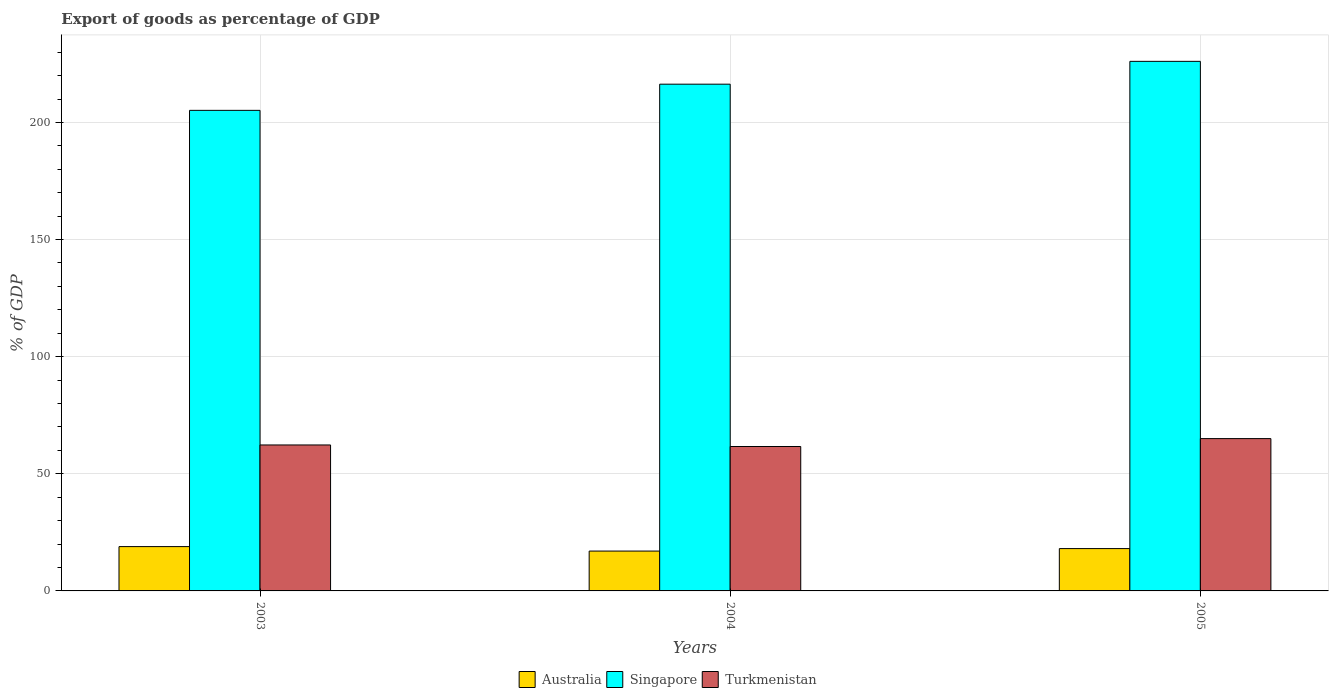Are the number of bars per tick equal to the number of legend labels?
Provide a succinct answer. Yes. How many bars are there on the 2nd tick from the right?
Your response must be concise. 3. What is the export of goods as percentage of GDP in Turkmenistan in 2005?
Provide a short and direct response. 65.03. Across all years, what is the maximum export of goods as percentage of GDP in Turkmenistan?
Offer a very short reply. 65.03. Across all years, what is the minimum export of goods as percentage of GDP in Singapore?
Give a very brief answer. 205.16. In which year was the export of goods as percentage of GDP in Australia maximum?
Provide a succinct answer. 2003. In which year was the export of goods as percentage of GDP in Turkmenistan minimum?
Keep it short and to the point. 2004. What is the total export of goods as percentage of GDP in Australia in the graph?
Your answer should be compact. 54.01. What is the difference between the export of goods as percentage of GDP in Australia in 2003 and that in 2004?
Offer a very short reply. 1.91. What is the difference between the export of goods as percentage of GDP in Turkmenistan in 2005 and the export of goods as percentage of GDP in Singapore in 2004?
Ensure brevity in your answer.  -151.31. What is the average export of goods as percentage of GDP in Singapore per year?
Provide a succinct answer. 215.86. In the year 2005, what is the difference between the export of goods as percentage of GDP in Australia and export of goods as percentage of GDP in Turkmenistan?
Provide a succinct answer. -46.95. In how many years, is the export of goods as percentage of GDP in Turkmenistan greater than 170 %?
Your answer should be compact. 0. What is the ratio of the export of goods as percentage of GDP in Turkmenistan in 2003 to that in 2005?
Keep it short and to the point. 0.96. Is the difference between the export of goods as percentage of GDP in Australia in 2003 and 2005 greater than the difference between the export of goods as percentage of GDP in Turkmenistan in 2003 and 2005?
Ensure brevity in your answer.  Yes. What is the difference between the highest and the second highest export of goods as percentage of GDP in Turkmenistan?
Ensure brevity in your answer.  2.72. What is the difference between the highest and the lowest export of goods as percentage of GDP in Singapore?
Your answer should be very brief. 20.92. In how many years, is the export of goods as percentage of GDP in Turkmenistan greater than the average export of goods as percentage of GDP in Turkmenistan taken over all years?
Provide a short and direct response. 1. Is the sum of the export of goods as percentage of GDP in Singapore in 2003 and 2005 greater than the maximum export of goods as percentage of GDP in Turkmenistan across all years?
Provide a succinct answer. Yes. What does the 2nd bar from the left in 2004 represents?
Keep it short and to the point. Singapore. Are all the bars in the graph horizontal?
Give a very brief answer. No. How many years are there in the graph?
Give a very brief answer. 3. Where does the legend appear in the graph?
Keep it short and to the point. Bottom center. How many legend labels are there?
Make the answer very short. 3. How are the legend labels stacked?
Keep it short and to the point. Horizontal. What is the title of the graph?
Provide a succinct answer. Export of goods as percentage of GDP. Does "United Kingdom" appear as one of the legend labels in the graph?
Keep it short and to the point. No. What is the label or title of the Y-axis?
Your response must be concise. % of GDP. What is the % of GDP of Australia in 2003?
Offer a very short reply. 18.92. What is the % of GDP in Singapore in 2003?
Your answer should be compact. 205.16. What is the % of GDP of Turkmenistan in 2003?
Give a very brief answer. 62.31. What is the % of GDP in Australia in 2004?
Your answer should be compact. 17.01. What is the % of GDP in Singapore in 2004?
Ensure brevity in your answer.  216.34. What is the % of GDP of Turkmenistan in 2004?
Your answer should be compact. 61.65. What is the % of GDP of Australia in 2005?
Offer a very short reply. 18.07. What is the % of GDP in Singapore in 2005?
Ensure brevity in your answer.  226.08. What is the % of GDP of Turkmenistan in 2005?
Keep it short and to the point. 65.03. Across all years, what is the maximum % of GDP of Australia?
Provide a short and direct response. 18.92. Across all years, what is the maximum % of GDP of Singapore?
Give a very brief answer. 226.08. Across all years, what is the maximum % of GDP in Turkmenistan?
Give a very brief answer. 65.03. Across all years, what is the minimum % of GDP in Australia?
Provide a succinct answer. 17.01. Across all years, what is the minimum % of GDP in Singapore?
Keep it short and to the point. 205.16. Across all years, what is the minimum % of GDP of Turkmenistan?
Your answer should be very brief. 61.65. What is the total % of GDP of Australia in the graph?
Your answer should be very brief. 54.01. What is the total % of GDP of Singapore in the graph?
Provide a short and direct response. 647.58. What is the total % of GDP in Turkmenistan in the graph?
Provide a succinct answer. 188.99. What is the difference between the % of GDP in Australia in 2003 and that in 2004?
Give a very brief answer. 1.91. What is the difference between the % of GDP in Singapore in 2003 and that in 2004?
Provide a succinct answer. -11.17. What is the difference between the % of GDP of Turkmenistan in 2003 and that in 2004?
Offer a terse response. 0.66. What is the difference between the % of GDP of Australia in 2003 and that in 2005?
Give a very brief answer. 0.85. What is the difference between the % of GDP in Singapore in 2003 and that in 2005?
Provide a succinct answer. -20.92. What is the difference between the % of GDP of Turkmenistan in 2003 and that in 2005?
Your answer should be compact. -2.72. What is the difference between the % of GDP in Australia in 2004 and that in 2005?
Keep it short and to the point. -1.06. What is the difference between the % of GDP of Singapore in 2004 and that in 2005?
Provide a succinct answer. -9.74. What is the difference between the % of GDP of Turkmenistan in 2004 and that in 2005?
Offer a terse response. -3.37. What is the difference between the % of GDP in Australia in 2003 and the % of GDP in Singapore in 2004?
Your response must be concise. -197.41. What is the difference between the % of GDP of Australia in 2003 and the % of GDP of Turkmenistan in 2004?
Give a very brief answer. -42.73. What is the difference between the % of GDP in Singapore in 2003 and the % of GDP in Turkmenistan in 2004?
Give a very brief answer. 143.51. What is the difference between the % of GDP in Australia in 2003 and the % of GDP in Singapore in 2005?
Provide a short and direct response. -207.16. What is the difference between the % of GDP in Australia in 2003 and the % of GDP in Turkmenistan in 2005?
Offer a terse response. -46.1. What is the difference between the % of GDP of Singapore in 2003 and the % of GDP of Turkmenistan in 2005?
Your response must be concise. 140.13. What is the difference between the % of GDP of Australia in 2004 and the % of GDP of Singapore in 2005?
Keep it short and to the point. -209.07. What is the difference between the % of GDP of Australia in 2004 and the % of GDP of Turkmenistan in 2005?
Your answer should be compact. -48.01. What is the difference between the % of GDP of Singapore in 2004 and the % of GDP of Turkmenistan in 2005?
Offer a terse response. 151.31. What is the average % of GDP in Australia per year?
Make the answer very short. 18. What is the average % of GDP in Singapore per year?
Make the answer very short. 215.86. What is the average % of GDP in Turkmenistan per year?
Offer a terse response. 63. In the year 2003, what is the difference between the % of GDP in Australia and % of GDP in Singapore?
Your answer should be very brief. -186.24. In the year 2003, what is the difference between the % of GDP of Australia and % of GDP of Turkmenistan?
Provide a succinct answer. -43.39. In the year 2003, what is the difference between the % of GDP of Singapore and % of GDP of Turkmenistan?
Keep it short and to the point. 142.85. In the year 2004, what is the difference between the % of GDP in Australia and % of GDP in Singapore?
Give a very brief answer. -199.32. In the year 2004, what is the difference between the % of GDP in Australia and % of GDP in Turkmenistan?
Provide a short and direct response. -44.64. In the year 2004, what is the difference between the % of GDP in Singapore and % of GDP in Turkmenistan?
Offer a terse response. 154.68. In the year 2005, what is the difference between the % of GDP in Australia and % of GDP in Singapore?
Ensure brevity in your answer.  -208. In the year 2005, what is the difference between the % of GDP of Australia and % of GDP of Turkmenistan?
Make the answer very short. -46.95. In the year 2005, what is the difference between the % of GDP of Singapore and % of GDP of Turkmenistan?
Provide a short and direct response. 161.05. What is the ratio of the % of GDP in Australia in 2003 to that in 2004?
Offer a very short reply. 1.11. What is the ratio of the % of GDP in Singapore in 2003 to that in 2004?
Offer a very short reply. 0.95. What is the ratio of the % of GDP in Turkmenistan in 2003 to that in 2004?
Offer a very short reply. 1.01. What is the ratio of the % of GDP of Australia in 2003 to that in 2005?
Provide a succinct answer. 1.05. What is the ratio of the % of GDP in Singapore in 2003 to that in 2005?
Make the answer very short. 0.91. What is the ratio of the % of GDP in Turkmenistan in 2003 to that in 2005?
Your response must be concise. 0.96. What is the ratio of the % of GDP in Australia in 2004 to that in 2005?
Your response must be concise. 0.94. What is the ratio of the % of GDP in Singapore in 2004 to that in 2005?
Keep it short and to the point. 0.96. What is the ratio of the % of GDP in Turkmenistan in 2004 to that in 2005?
Make the answer very short. 0.95. What is the difference between the highest and the second highest % of GDP of Australia?
Your answer should be compact. 0.85. What is the difference between the highest and the second highest % of GDP of Singapore?
Keep it short and to the point. 9.74. What is the difference between the highest and the second highest % of GDP of Turkmenistan?
Your response must be concise. 2.72. What is the difference between the highest and the lowest % of GDP in Australia?
Provide a succinct answer. 1.91. What is the difference between the highest and the lowest % of GDP of Singapore?
Your answer should be compact. 20.92. What is the difference between the highest and the lowest % of GDP in Turkmenistan?
Offer a very short reply. 3.37. 